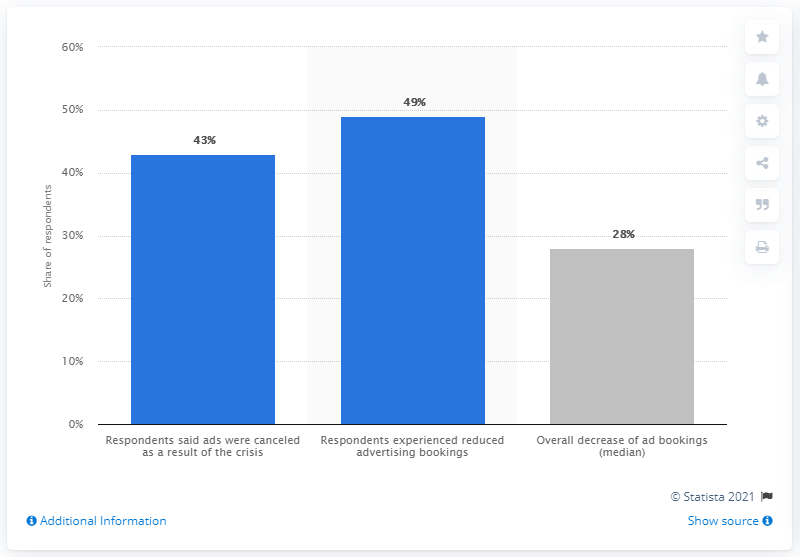Give some essential details in this illustration. The ad bookings for magazines published in Sweden decreased by 28% in the past year. 